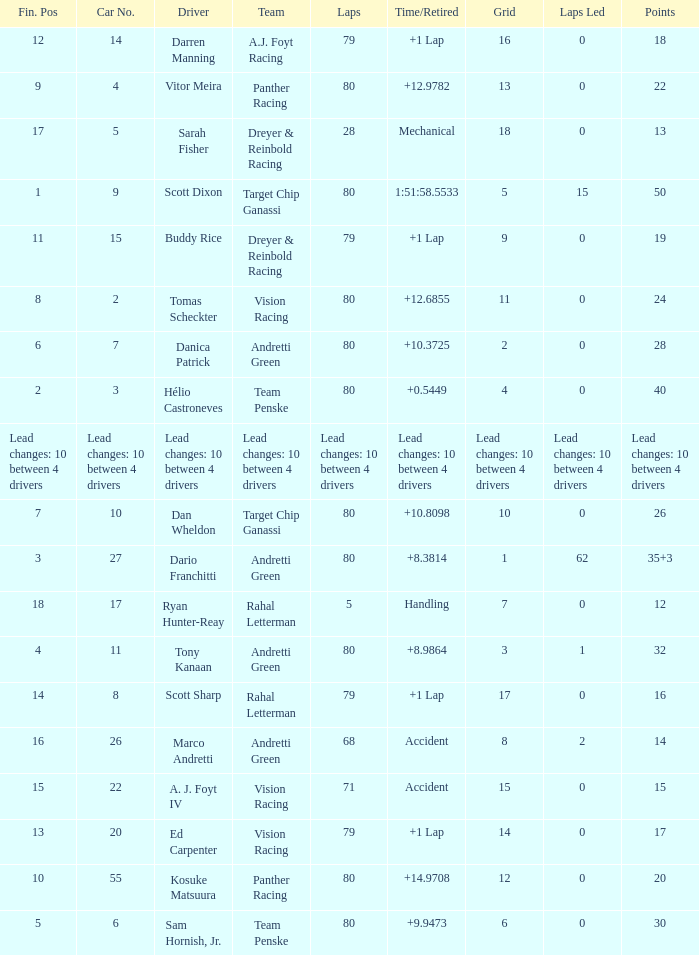Which team has 26 points? Target Chip Ganassi. Give me the full table as a dictionary. {'header': ['Fin. Pos', 'Car No.', 'Driver', 'Team', 'Laps', 'Time/Retired', 'Grid', 'Laps Led', 'Points'], 'rows': [['12', '14', 'Darren Manning', 'A.J. Foyt Racing', '79', '+1 Lap', '16', '0', '18'], ['9', '4', 'Vitor Meira', 'Panther Racing', '80', '+12.9782', '13', '0', '22'], ['17', '5', 'Sarah Fisher', 'Dreyer & Reinbold Racing', '28', 'Mechanical', '18', '0', '13'], ['1', '9', 'Scott Dixon', 'Target Chip Ganassi', '80', '1:51:58.5533', '5', '15', '50'], ['11', '15', 'Buddy Rice', 'Dreyer & Reinbold Racing', '79', '+1 Lap', '9', '0', '19'], ['8', '2', 'Tomas Scheckter', 'Vision Racing', '80', '+12.6855', '11', '0', '24'], ['6', '7', 'Danica Patrick', 'Andretti Green', '80', '+10.3725', '2', '0', '28'], ['2', '3', 'Hélio Castroneves', 'Team Penske', '80', '+0.5449', '4', '0', '40'], ['Lead changes: 10 between 4 drivers', 'Lead changes: 10 between 4 drivers', 'Lead changes: 10 between 4 drivers', 'Lead changes: 10 between 4 drivers', 'Lead changes: 10 between 4 drivers', 'Lead changes: 10 between 4 drivers', 'Lead changes: 10 between 4 drivers', 'Lead changes: 10 between 4 drivers', 'Lead changes: 10 between 4 drivers'], ['7', '10', 'Dan Wheldon', 'Target Chip Ganassi', '80', '+10.8098', '10', '0', '26'], ['3', '27', 'Dario Franchitti', 'Andretti Green', '80', '+8.3814', '1', '62', '35+3'], ['18', '17', 'Ryan Hunter-Reay', 'Rahal Letterman', '5', 'Handling', '7', '0', '12'], ['4', '11', 'Tony Kanaan', 'Andretti Green', '80', '+8.9864', '3', '1', '32'], ['14', '8', 'Scott Sharp', 'Rahal Letterman', '79', '+1 Lap', '17', '0', '16'], ['16', '26', 'Marco Andretti', 'Andretti Green', '68', 'Accident', '8', '2', '14'], ['15', '22', 'A. J. Foyt IV', 'Vision Racing', '71', 'Accident', '15', '0', '15'], ['13', '20', 'Ed Carpenter', 'Vision Racing', '79', '+1 Lap', '14', '0', '17'], ['10', '55', 'Kosuke Matsuura', 'Panther Racing', '80', '+14.9708', '12', '0', '20'], ['5', '6', 'Sam Hornish, Jr.', 'Team Penske', '80', '+9.9473', '6', '0', '30']]} 